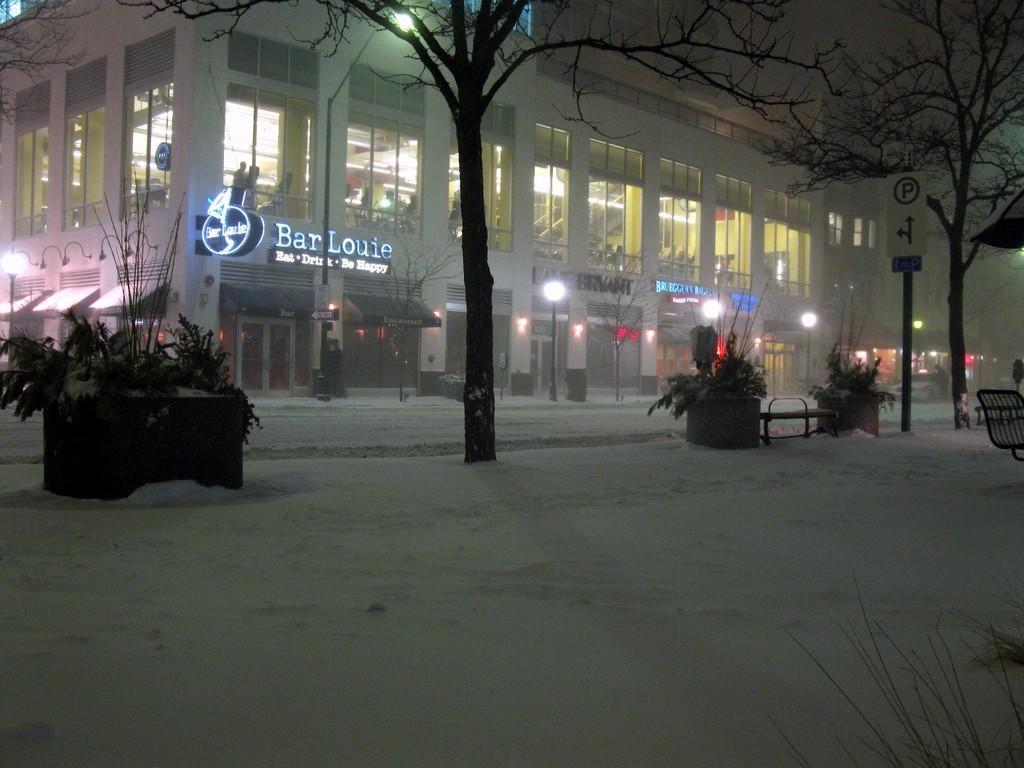Could you give a brief overview of what you see in this image? In this image we can see buildings, street lights, a board attached to the building, a sign board, few plants, trees, a bench and a chair. 